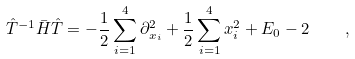<formula> <loc_0><loc_0><loc_500><loc_500>\hat { T } ^ { - 1 } \bar { H } \hat { T } = - \frac { 1 } { 2 } \sum _ { i = 1 } ^ { 4 } \partial _ { x _ { i } } ^ { 2 } + \frac { 1 } { 2 } \sum _ { i = 1 } ^ { 4 } x _ { i } ^ { 2 } + E _ { 0 } - 2 \quad ,</formula> 